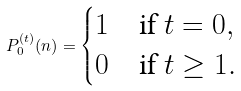Convert formula to latex. <formula><loc_0><loc_0><loc_500><loc_500>P _ { 0 } ^ { ( t ) } ( n ) = \begin{cases} 1 & \text {if $t=0$} , \\ 0 & \text {if $t\geq1$} . \end{cases}</formula> 